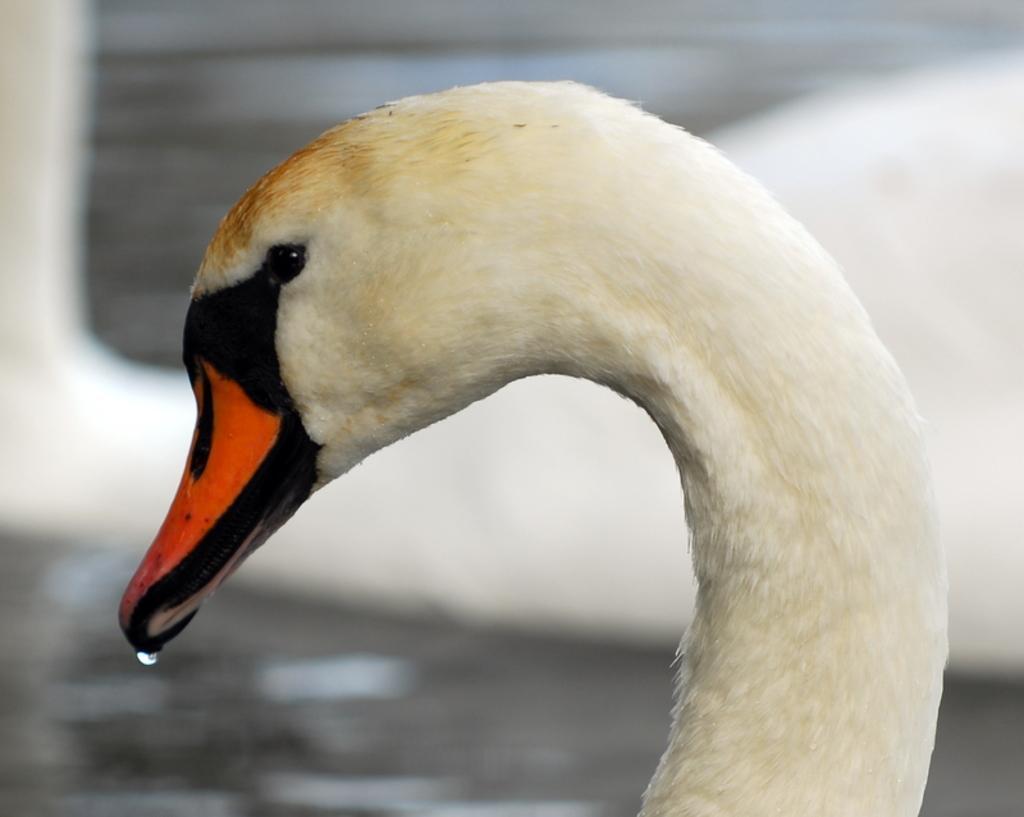Please provide a concise description of this image. This image is taken outdoors. In the background there is a swan in the water. In the middle of the middle of the image there is another swan which is white in color. At the bottom of the image there is a pond with water. 